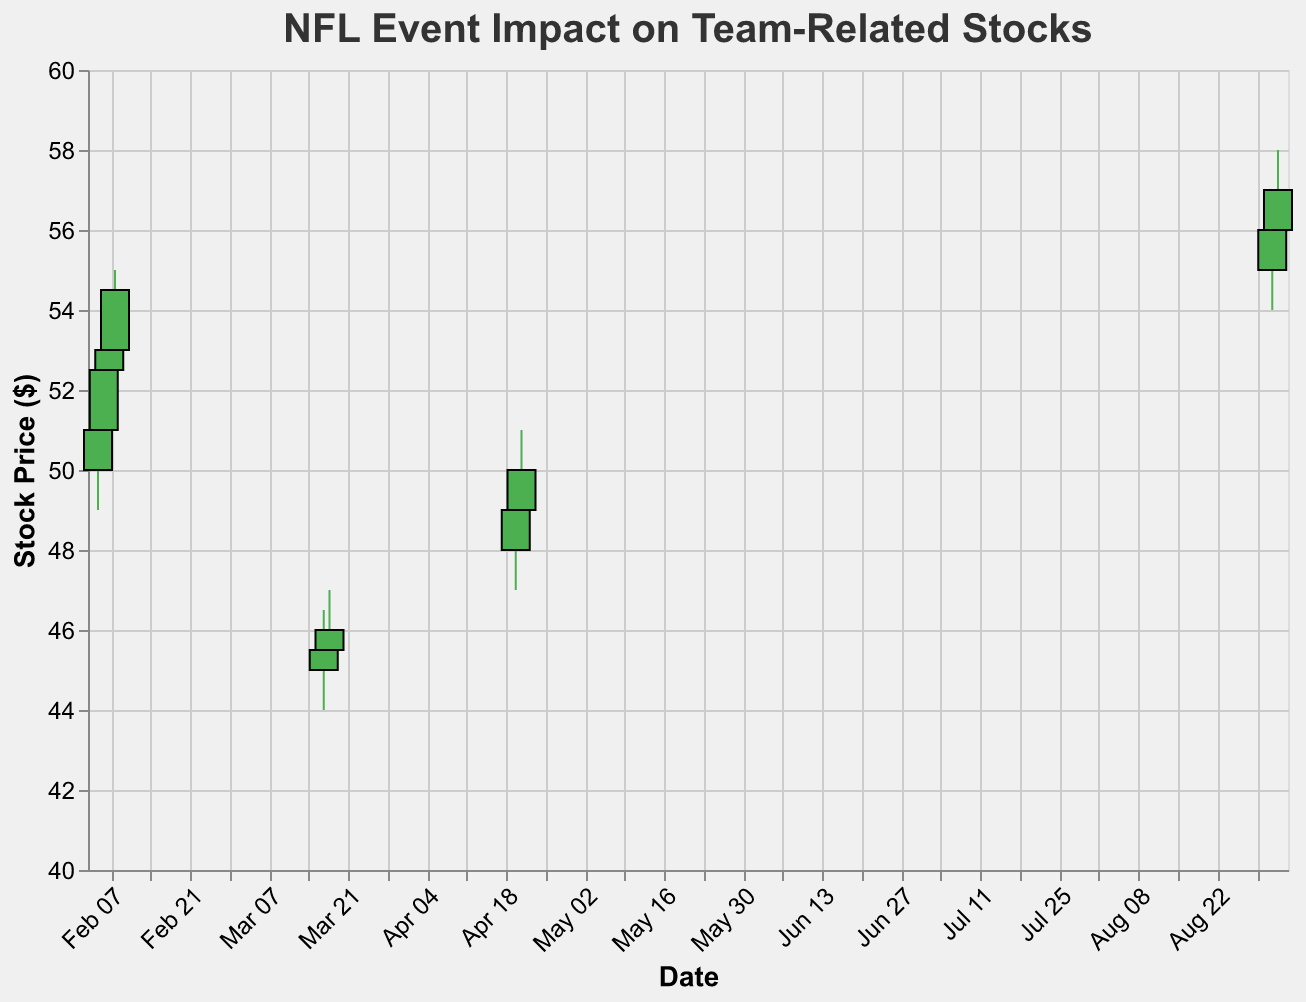What event is associated with the highest volume on the plot? The highest volume on the plot is 2,500,000, which occurs on "2021-02-08". The event associated with this date is "Super Bowl Win" by Tampa Bay Buccaneers.
Answer: Super Bowl Win What is the stock price range (high minus low) on 2021-03-17? The high price on 2021-03-17 is 46.50, and the low price is 44.00. Subtracting the low from the high gives the range: 46.50 - 44.00 = 2.50.
Answer: 2.50 How did the stock price change from the Super Bowl Announcement to the Super Bowl Win for Kansas City Chiefs? On 2021-02-05, the close price is 51.00, and on 2021-02-06, the close price is 52.50. The increase is 52.50 - 51.00 = 1.50. However, the Kansas City Chiefs didn't win, so the increase ends there.
Answer: Increased by 1.50 Which event caused the biggest increase in stock price from open to close on a single day? To find the biggest increase, we look at the difference between the open and close prices for each date. The day with the largest increase is "2021-02-08" when the price increased from 53.00 to 54.50. The increase is 54.50 - 53.00 = 1.50.
Answer: Super Bowl Win (for Tampa Bay Buccaneers) How many days show an increase in their closing stock price compared to their opening price? To determine this, we look at each day where the close price is higher than the open price. The dates are 2021-02-05, 2021-02-06, 2021-02-08, 2021-04-21, 2021-09-01, and 2021-09-02. There are 6 such days.
Answer: 6 What is the closing price on the day of Player Trade involving Kansas City Chiefs? The "Player Trade" event happened on 2021-03-17 and 2021-03-18. The closing prices are 45.50 on 2021-03-17 and 46.00 on 2021-03-18.
Answer: 45.50 and 46.00 Which team had the highest stock price on the date of their event? To find the highest stock price, we look for the highest closing price in the dataset. The highest closing price is 57.00 on 2021-09-02, associated with the "Season Opening" for Dallas Cowboys.
Answer: Dallas Cowboys How did the volume change before and after the Super Bowl? The volumes before and after the Super Bowl on 2021-02-05, 2021-02-06, 2021-02-07, and 2021-02-08 are 1,000,000, 1,500,000, 2,000,000, and 2,500,000 respectively. The volume increased each day leading up to and following the Super Bowl.
Answer: Increased On which day did the Cleveland Browns have higher closing stock prices? The Cleveland Browns had events on 2021-04-20 and 2021-04-21. The closing prices were 49.00 on 2021-04-20 and 50.00 on 2021-04-21. The higher closing price was on 2021-04-21.
Answer: 2021-04-21 Which event had the smallest change in stock price from open to close on a single day? To find the smallest change, we calculate the difference between open and close prices. The smallest change of 0.50 occurs on 2021-03-18 when the stock price changed from 45.50 to 46.00.
Answer: Player Trade on 2021-03-18 